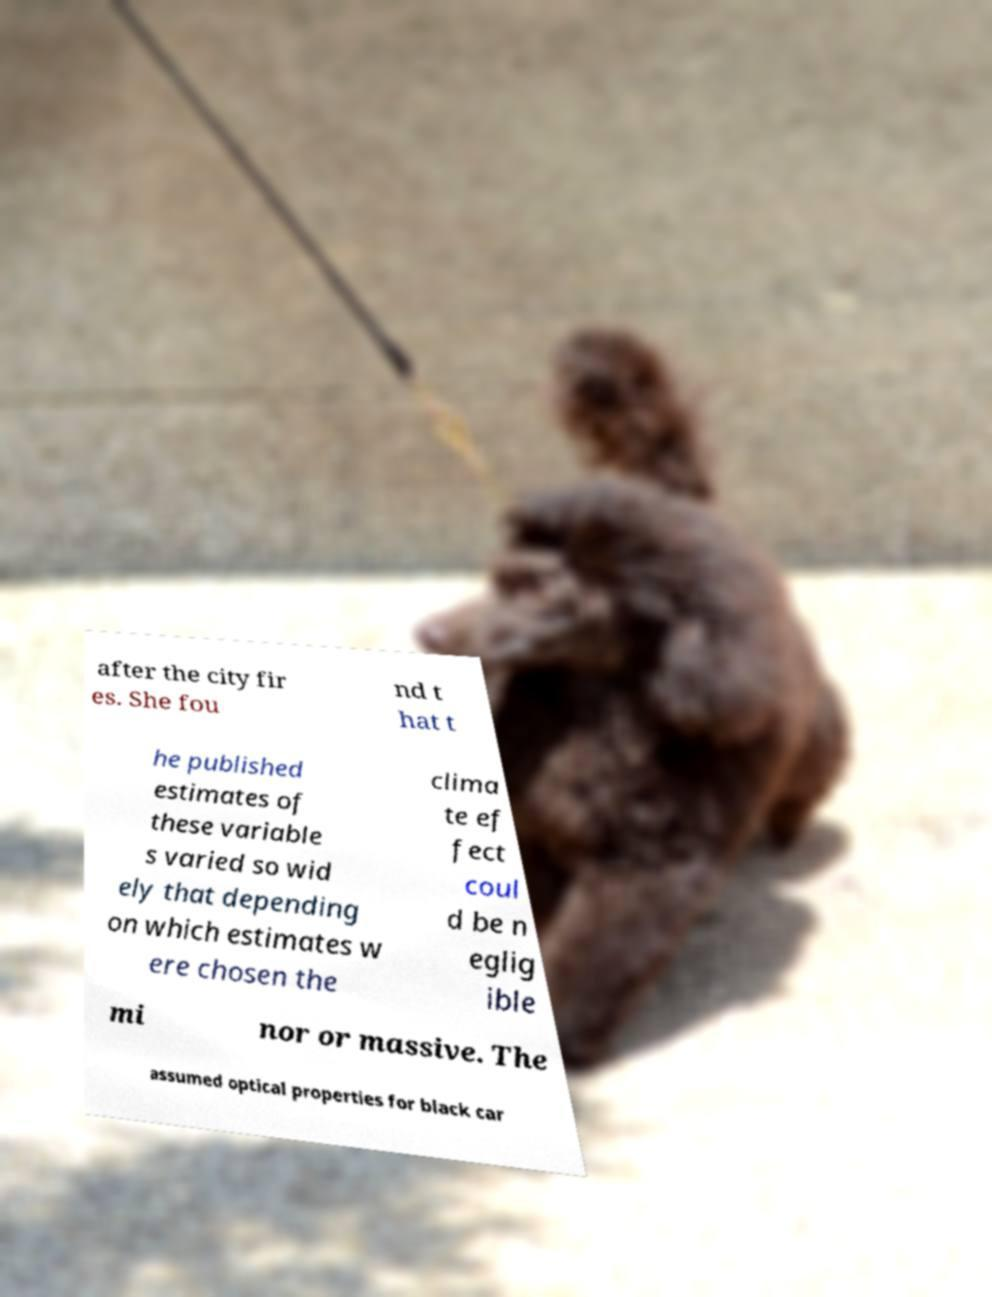Please identify and transcribe the text found in this image. after the city fir es. She fou nd t hat t he published estimates of these variable s varied so wid ely that depending on which estimates w ere chosen the clima te ef fect coul d be n eglig ible mi nor or massive. The assumed optical properties for black car 